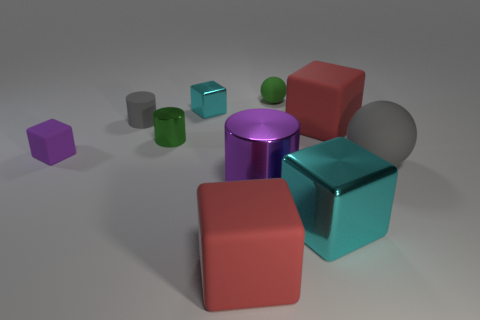How does the lighting in the scene affect the appearance of the objects? The lighting in the scene casts soft shadows and highlights on the objects, enhancing their three-dimensional form. The light source seems to be coming from the upper left side, and it brings out the reflective qualities of some objects more than others, emphasizing their textures and adding depth to the overall composition. 